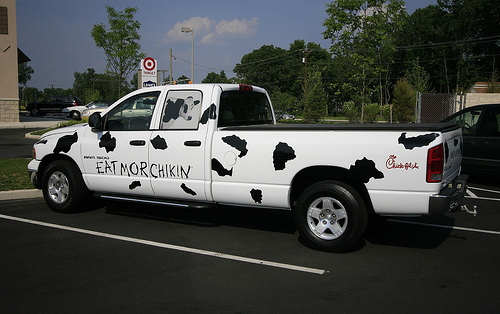<image>
Is the truck in front of the tire? No. The truck is not in front of the tire. The spatial positioning shows a different relationship between these objects. 